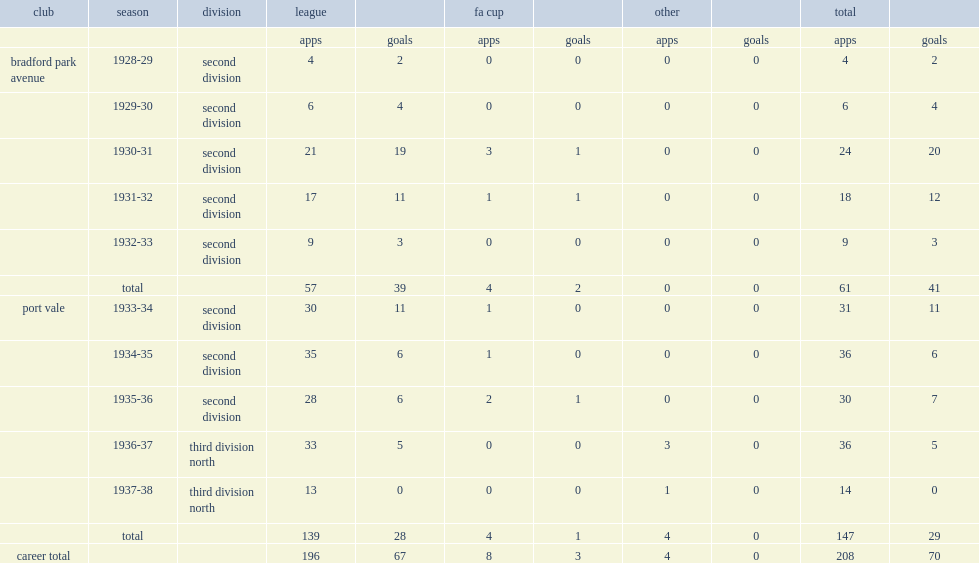How many goals did trevor rhodes make in 147 league and cup games? 29.0. 